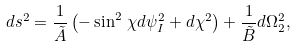Convert formula to latex. <formula><loc_0><loc_0><loc_500><loc_500>d s ^ { 2 } = \frac { 1 } { \tilde { A } } \left ( - \sin ^ { 2 } \, \chi d \psi _ { I } ^ { 2 } + d \chi ^ { 2 } \right ) + \frac { 1 } { \tilde { B } } d \Omega _ { 2 } ^ { 2 } ,</formula> 